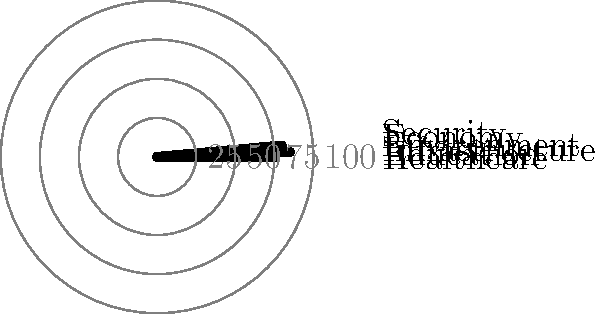The polar bar chart above represents your legislative success rates in various policy areas. Which policy area shows the highest success rate, and what potential talking points could you emphasize during a press conference to highlight your achievements in this area? To answer this question, we need to follow these steps:

1. Identify the policy areas represented in the chart:
   - Healthcare
   - Education
   - Infrastructure
   - Environment
   - Economy
   - Security

2. Compare the lengths of the bars to determine the highest success rate:
   - The longest bar corresponds to Infrastructure, indicating the highest success rate.

3. Determine the approximate success rate for Infrastructure:
   - The Infrastructure bar extends to the third concentric circle.
   - Each circle represents 25% (as labeled on the right side of the chart).
   - The bar slightly exceeds the third circle, suggesting a success rate of approximately 85%.

4. Develop potential talking points for a press conference:
   a) Highlight the 85% success rate in Infrastructure legislation.
   b) Emphasize specific infrastructure projects that have been approved or completed.
   c) Discuss the positive impact of these projects on job creation and economic growth.
   d) Mention any bipartisan support received for these initiatives.
   e) Connect infrastructure improvements to other policy areas, such as economic development and environmental sustainability.

By focusing on the Infrastructure success rate and its broader implications, you can effectively communicate your legislative achievements to the media and public.
Answer: Infrastructure (85%); emphasize job creation, economic growth, and bipartisan support for approved projects. 